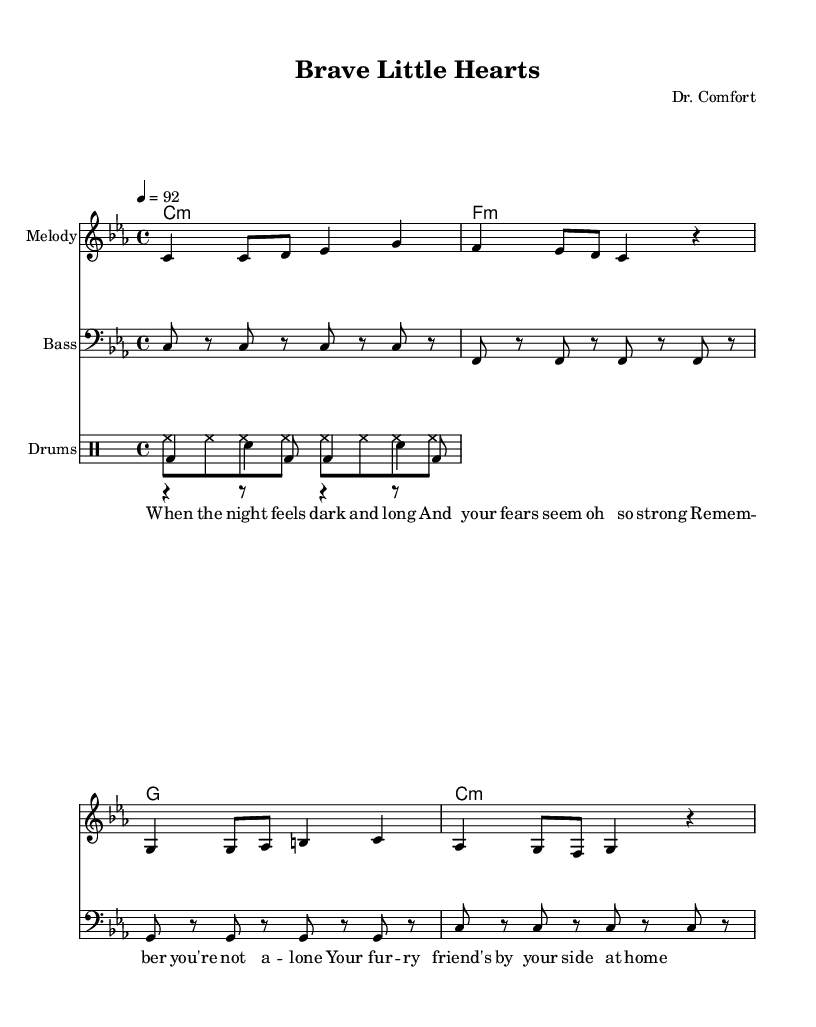What is the key signature of this music? The key signature is C minor, which has three flats (B flat, E flat, A flat), indicated by the 'key c minor' in the global section.
Answer: C minor What is the time signature of this music? The time signature is 4/4, which is visible in the global section of the code and means there are 4 beats per measure.
Answer: 4/4 What is the tempo of the piece? The tempo is set at 92 beats per minute, as noted by '4 = 92' in the global section, informing the speed of the music.
Answer: 92 What type of musical instruments are used in this piece? The piece features a melody, bass, and drums, which are highlighted by the different staff labels: "Melody," "Bass," and "Drums."
Answer: Melody, Bass, Drums What is the main theme expressed in the lyrics? The lyrics focus on companionship and overcoming fear, as shown in the words about night, strong fears, and furry friends by your side.
Answer: Companionship and overcoming fear Which musical genre does this piece belong to? The overall style, structure, and rhythmic elements, including the drum patterns, indicate that this piece is classified as Hip Hop.
Answer: Hip Hop 